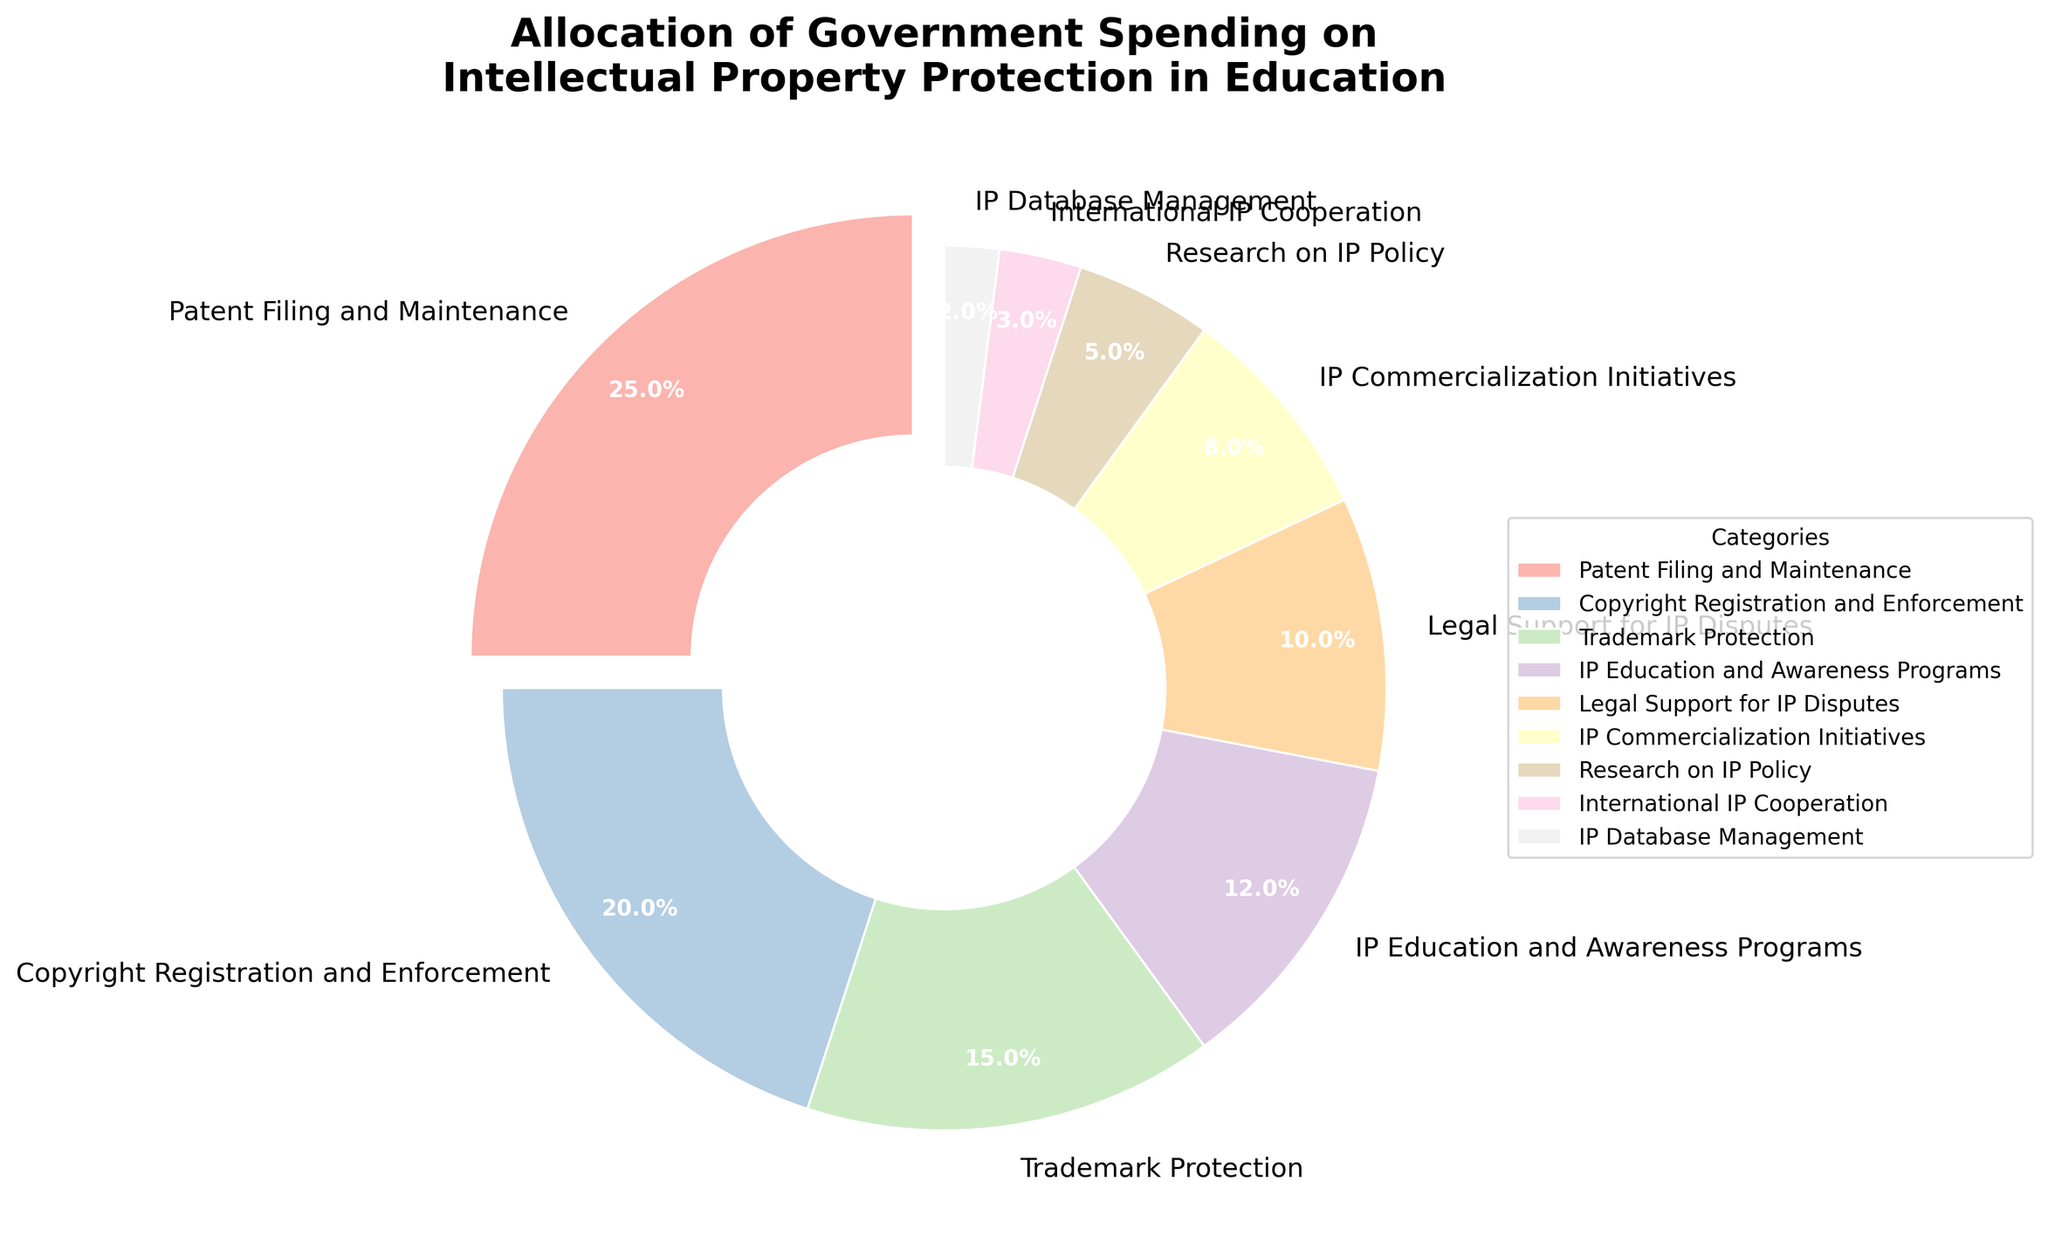What percentage of the budget is allocated to Patent Filing and Maintenance? Patent Filing and Maintenance accounts for 25% as shown in the pie chart.
Answer: 25% How much more is allocated to Patent Filing and Maintenance compared to IP Commercialization Initiatives? Patent Filing and Maintenance is allocated 25%, and IP Commercialization Initiatives is allocated 8%. The difference is 25% - 8% = 17%.
Answer: 17% What are the two categories with the lowest budget allocation? The pie chart shows that the two smallest segments are International IP Cooperation with 3% and IP Database Management with 2%.
Answer: International IP Cooperation and IP Database Management What percentage of the budget is allocated to Copyright Registration and Enforcement and Trademark Protection combined? Copyright Registration and Enforcement is 20% and Trademark Protection is 15%. Their combined percentage is 20% + 15% = 35%.
Answer: 35% How does the allocation for IP Education and Awareness Programs compare to that for Legal Support for IP Disputes? IP Education and Awareness Programs is allocated 12% while Legal Support for IP Disputes gets 10%. IP Education and Awareness Programs has 2% more allocation than Legal Support for IP Disputes.
Answer: 2% more Which category has the largest slice in the pie chart? The largest slice, indicated by it being slightly detached (exploded) from the chart, is for Patent Filing and Maintenance, which has 25%.
Answer: Patent Filing and Maintenance Sum of budgets allocated to categories in IP protection excluding the top 3? The top three categories are Patent Filing and Maintenance (25%), Copyright Registration and Enforcement (20%), and Trademark Protection (15%) which totals to 25% + 20% + 15% = 60%. The remaining sum is 100% - 60% = 40%.
Answer: 40% If IP Commercialization Initiatives and Research on IP Policy were combined into one new category, how much of the budget would it represent? IP Commercialization Initiatives is 8% and Research on IP Policy is 5%. Combined, they sum up to 8% + 5% = 13%.
Answer: 13% What is the third most allocated category? The third most allocated category is Trademark Protection with 15%.
Answer: Trademark Protection 